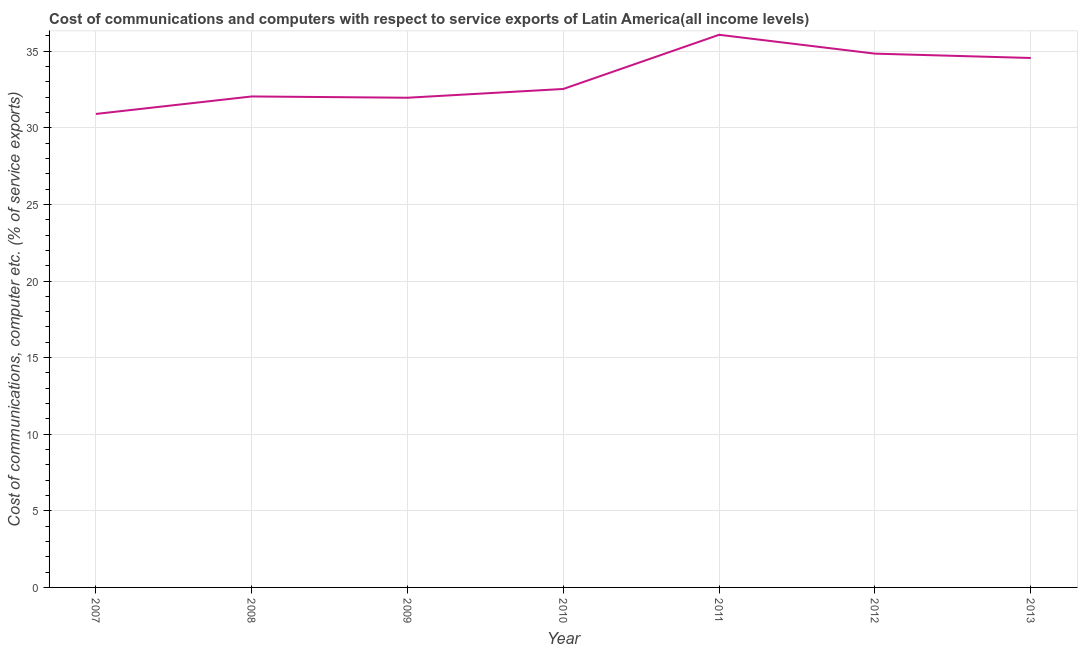What is the cost of communications and computer in 2012?
Provide a short and direct response. 34.84. Across all years, what is the maximum cost of communications and computer?
Keep it short and to the point. 36.07. Across all years, what is the minimum cost of communications and computer?
Ensure brevity in your answer.  30.91. In which year was the cost of communications and computer maximum?
Offer a terse response. 2011. What is the sum of the cost of communications and computer?
Offer a very short reply. 232.93. What is the difference between the cost of communications and computer in 2007 and 2013?
Keep it short and to the point. -3.65. What is the average cost of communications and computer per year?
Your response must be concise. 33.28. What is the median cost of communications and computer?
Keep it short and to the point. 32.54. In how many years, is the cost of communications and computer greater than 26 %?
Provide a short and direct response. 7. What is the ratio of the cost of communications and computer in 2008 to that in 2013?
Give a very brief answer. 0.93. Is the difference between the cost of communications and computer in 2007 and 2013 greater than the difference between any two years?
Offer a terse response. No. What is the difference between the highest and the second highest cost of communications and computer?
Offer a terse response. 1.23. Is the sum of the cost of communications and computer in 2009 and 2013 greater than the maximum cost of communications and computer across all years?
Make the answer very short. Yes. What is the difference between the highest and the lowest cost of communications and computer?
Ensure brevity in your answer.  5.17. Does the cost of communications and computer monotonically increase over the years?
Your answer should be very brief. No. How many years are there in the graph?
Make the answer very short. 7. Are the values on the major ticks of Y-axis written in scientific E-notation?
Offer a terse response. No. Does the graph contain any zero values?
Make the answer very short. No. What is the title of the graph?
Provide a succinct answer. Cost of communications and computers with respect to service exports of Latin America(all income levels). What is the label or title of the Y-axis?
Make the answer very short. Cost of communications, computer etc. (% of service exports). What is the Cost of communications, computer etc. (% of service exports) of 2007?
Make the answer very short. 30.91. What is the Cost of communications, computer etc. (% of service exports) in 2008?
Your response must be concise. 32.05. What is the Cost of communications, computer etc. (% of service exports) in 2009?
Your answer should be compact. 31.96. What is the Cost of communications, computer etc. (% of service exports) in 2010?
Offer a very short reply. 32.54. What is the Cost of communications, computer etc. (% of service exports) in 2011?
Give a very brief answer. 36.07. What is the Cost of communications, computer etc. (% of service exports) of 2012?
Provide a short and direct response. 34.84. What is the Cost of communications, computer etc. (% of service exports) of 2013?
Your answer should be compact. 34.56. What is the difference between the Cost of communications, computer etc. (% of service exports) in 2007 and 2008?
Offer a terse response. -1.14. What is the difference between the Cost of communications, computer etc. (% of service exports) in 2007 and 2009?
Offer a very short reply. -1.06. What is the difference between the Cost of communications, computer etc. (% of service exports) in 2007 and 2010?
Provide a short and direct response. -1.63. What is the difference between the Cost of communications, computer etc. (% of service exports) in 2007 and 2011?
Offer a terse response. -5.17. What is the difference between the Cost of communications, computer etc. (% of service exports) in 2007 and 2012?
Your response must be concise. -3.94. What is the difference between the Cost of communications, computer etc. (% of service exports) in 2007 and 2013?
Make the answer very short. -3.65. What is the difference between the Cost of communications, computer etc. (% of service exports) in 2008 and 2009?
Your response must be concise. 0.08. What is the difference between the Cost of communications, computer etc. (% of service exports) in 2008 and 2010?
Give a very brief answer. -0.49. What is the difference between the Cost of communications, computer etc. (% of service exports) in 2008 and 2011?
Make the answer very short. -4.03. What is the difference between the Cost of communications, computer etc. (% of service exports) in 2008 and 2012?
Your answer should be very brief. -2.79. What is the difference between the Cost of communications, computer etc. (% of service exports) in 2008 and 2013?
Provide a short and direct response. -2.51. What is the difference between the Cost of communications, computer etc. (% of service exports) in 2009 and 2010?
Keep it short and to the point. -0.57. What is the difference between the Cost of communications, computer etc. (% of service exports) in 2009 and 2011?
Offer a very short reply. -4.11. What is the difference between the Cost of communications, computer etc. (% of service exports) in 2009 and 2012?
Give a very brief answer. -2.88. What is the difference between the Cost of communications, computer etc. (% of service exports) in 2009 and 2013?
Ensure brevity in your answer.  -2.6. What is the difference between the Cost of communications, computer etc. (% of service exports) in 2010 and 2011?
Offer a terse response. -3.54. What is the difference between the Cost of communications, computer etc. (% of service exports) in 2010 and 2012?
Provide a succinct answer. -2.31. What is the difference between the Cost of communications, computer etc. (% of service exports) in 2010 and 2013?
Provide a short and direct response. -2.02. What is the difference between the Cost of communications, computer etc. (% of service exports) in 2011 and 2012?
Make the answer very short. 1.23. What is the difference between the Cost of communications, computer etc. (% of service exports) in 2011 and 2013?
Give a very brief answer. 1.51. What is the difference between the Cost of communications, computer etc. (% of service exports) in 2012 and 2013?
Keep it short and to the point. 0.28. What is the ratio of the Cost of communications, computer etc. (% of service exports) in 2007 to that in 2008?
Offer a very short reply. 0.96. What is the ratio of the Cost of communications, computer etc. (% of service exports) in 2007 to that in 2010?
Give a very brief answer. 0.95. What is the ratio of the Cost of communications, computer etc. (% of service exports) in 2007 to that in 2011?
Provide a short and direct response. 0.86. What is the ratio of the Cost of communications, computer etc. (% of service exports) in 2007 to that in 2012?
Offer a terse response. 0.89. What is the ratio of the Cost of communications, computer etc. (% of service exports) in 2007 to that in 2013?
Offer a very short reply. 0.89. What is the ratio of the Cost of communications, computer etc. (% of service exports) in 2008 to that in 2011?
Keep it short and to the point. 0.89. What is the ratio of the Cost of communications, computer etc. (% of service exports) in 2008 to that in 2013?
Your answer should be compact. 0.93. What is the ratio of the Cost of communications, computer etc. (% of service exports) in 2009 to that in 2011?
Provide a succinct answer. 0.89. What is the ratio of the Cost of communications, computer etc. (% of service exports) in 2009 to that in 2012?
Give a very brief answer. 0.92. What is the ratio of the Cost of communications, computer etc. (% of service exports) in 2009 to that in 2013?
Provide a succinct answer. 0.93. What is the ratio of the Cost of communications, computer etc. (% of service exports) in 2010 to that in 2011?
Your answer should be compact. 0.9. What is the ratio of the Cost of communications, computer etc. (% of service exports) in 2010 to that in 2012?
Your answer should be very brief. 0.93. What is the ratio of the Cost of communications, computer etc. (% of service exports) in 2010 to that in 2013?
Give a very brief answer. 0.94. What is the ratio of the Cost of communications, computer etc. (% of service exports) in 2011 to that in 2012?
Ensure brevity in your answer.  1.03. What is the ratio of the Cost of communications, computer etc. (% of service exports) in 2011 to that in 2013?
Your response must be concise. 1.04. What is the ratio of the Cost of communications, computer etc. (% of service exports) in 2012 to that in 2013?
Your answer should be very brief. 1.01. 